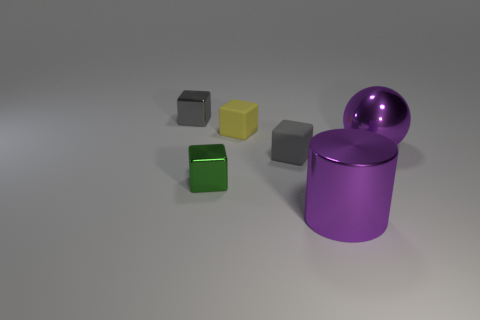How many objects are big objects or metal things left of the green thing?
Offer a very short reply. 3. Is the number of purple metal spheres that are left of the purple cylinder greater than the number of tiny blocks behind the small yellow matte object?
Make the answer very short. No. What shape is the tiny shiny object left of the tiny metallic object that is in front of the gray metallic thing behind the metal ball?
Make the answer very short. Cube. There is a tiny shiny thing to the left of the shiny block in front of the yellow block; what shape is it?
Give a very brief answer. Cube. Is there a small gray cube that has the same material as the green cube?
Your answer should be compact. Yes. The shiny cylinder that is the same color as the big shiny ball is what size?
Offer a very short reply. Large. What number of red things are either small cubes or large spheres?
Ensure brevity in your answer.  0. Are there any other cylinders of the same color as the metal cylinder?
Provide a succinct answer. No. There is a gray block that is the same material as the ball; what is its size?
Your answer should be very brief. Small. What number of blocks are either green objects or matte things?
Your answer should be compact. 3. 